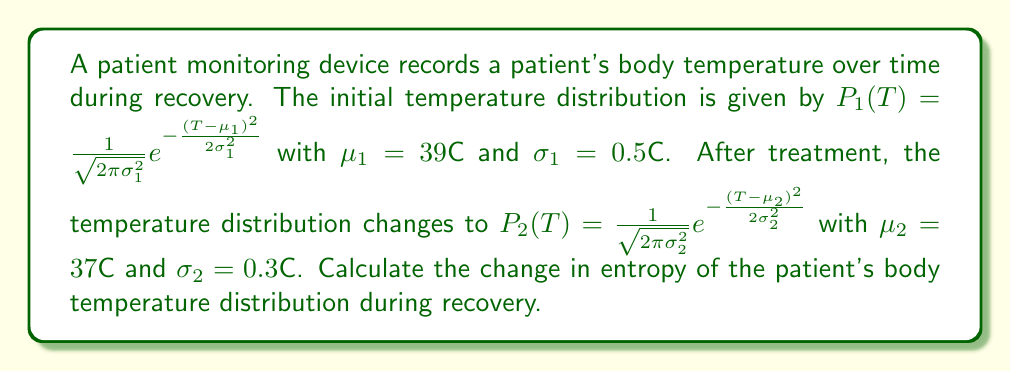What is the answer to this math problem? To calculate the change in entropy, we'll follow these steps:

1) The entropy of a continuous probability distribution is given by:
   $$S = -k_B \int P(T) \ln P(T) dT$$
   where $k_B$ is Boltzmann's constant.

2) For a Gaussian distribution, the entropy is:
   $$S = \frac{1}{2} k_B \ln(2\pi e \sigma^2)$$

3) Let's calculate the initial entropy $S_1$:
   $$S_1 = \frac{1}{2} k_B \ln(2\pi e \sigma_1^2) = \frac{1}{2} k_B \ln(2\pi e (0.5)^2)$$

4) Now calculate the final entropy $S_2$:
   $$S_2 = \frac{1}{2} k_B \ln(2\pi e \sigma_2^2) = \frac{1}{2} k_B \ln(2\pi e (0.3)^2)$$

5) The change in entropy is:
   $$\Delta S = S_2 - S_1 = \frac{1}{2} k_B \ln(2\pi e (0.3)^2) - \frac{1}{2} k_B \ln(2\pi e (0.5)^2)$$

6) Simplify:
   $$\Delta S = \frac{1}{2} k_B \ln(\frac{(0.3)^2}{(0.5)^2}) = \frac{1}{2} k_B \ln(0.36) = -0.511 k_B$$

Therefore, the change in entropy is $-0.511 k_B$.
Answer: $-0.511 k_B$ 